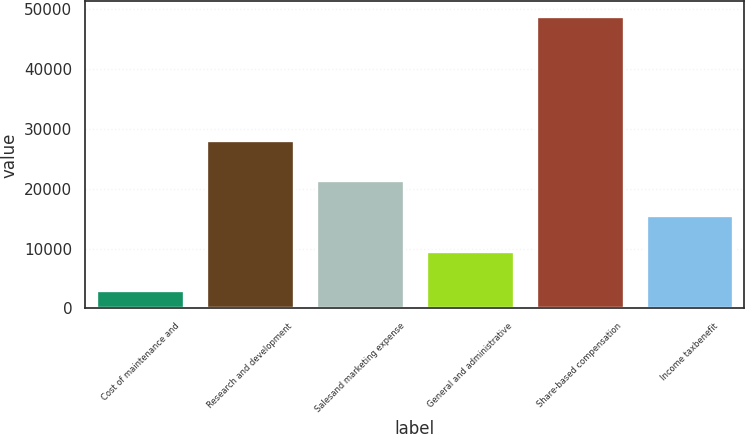Convert chart. <chart><loc_0><loc_0><loc_500><loc_500><bar_chart><fcel>Cost of maintenance and<fcel>Research and development<fcel>Salesand marketing expense<fcel>General and administrative<fcel>Share-based compensation<fcel>Income taxbenefit<nl><fcel>3103<fcel>28030<fcel>21514.4<fcel>9527<fcel>48827<fcel>15520.7<nl></chart> 